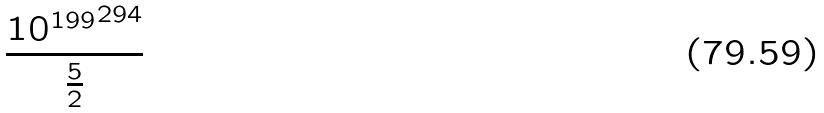Convert formula to latex. <formula><loc_0><loc_0><loc_500><loc_500>\frac { { 1 0 ^ { 1 9 9 } } ^ { 2 9 4 } } { \frac { 5 } { 2 } }</formula> 